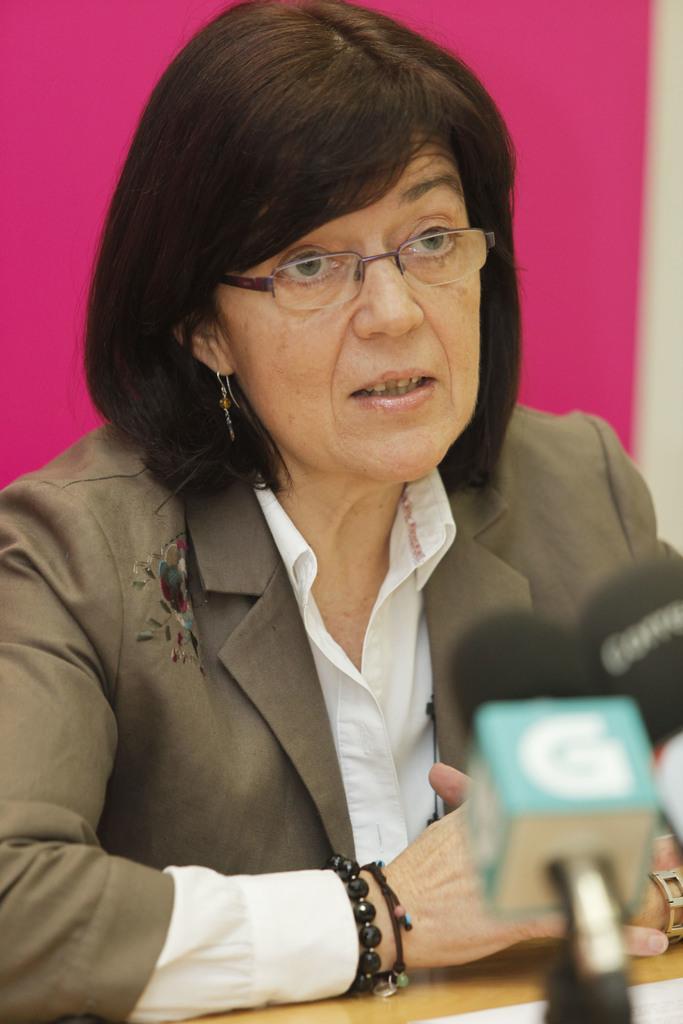Can you describe this image briefly? There is a woman wearing specs and bracelets. In front of her there is a table and mics. In the back there is a pink wall. 